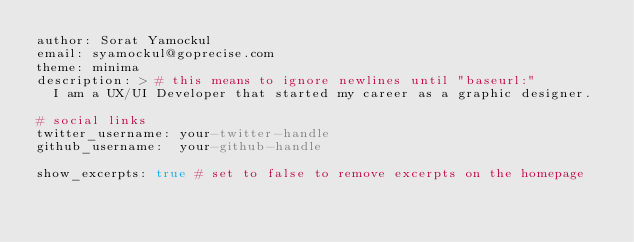<code> <loc_0><loc_0><loc_500><loc_500><_YAML_>author: Sorat Yamockul
email: syamockul@goprecise.com
theme: minima
description: > # this means to ignore newlines until "baseurl:"
  I am a UX/UI Developer that started my career as a graphic designer.

# social links
twitter_username: your-twitter-handle
github_username:  your-github-handle

show_excerpts: true # set to false to remove excerpts on the homepage
</code> 